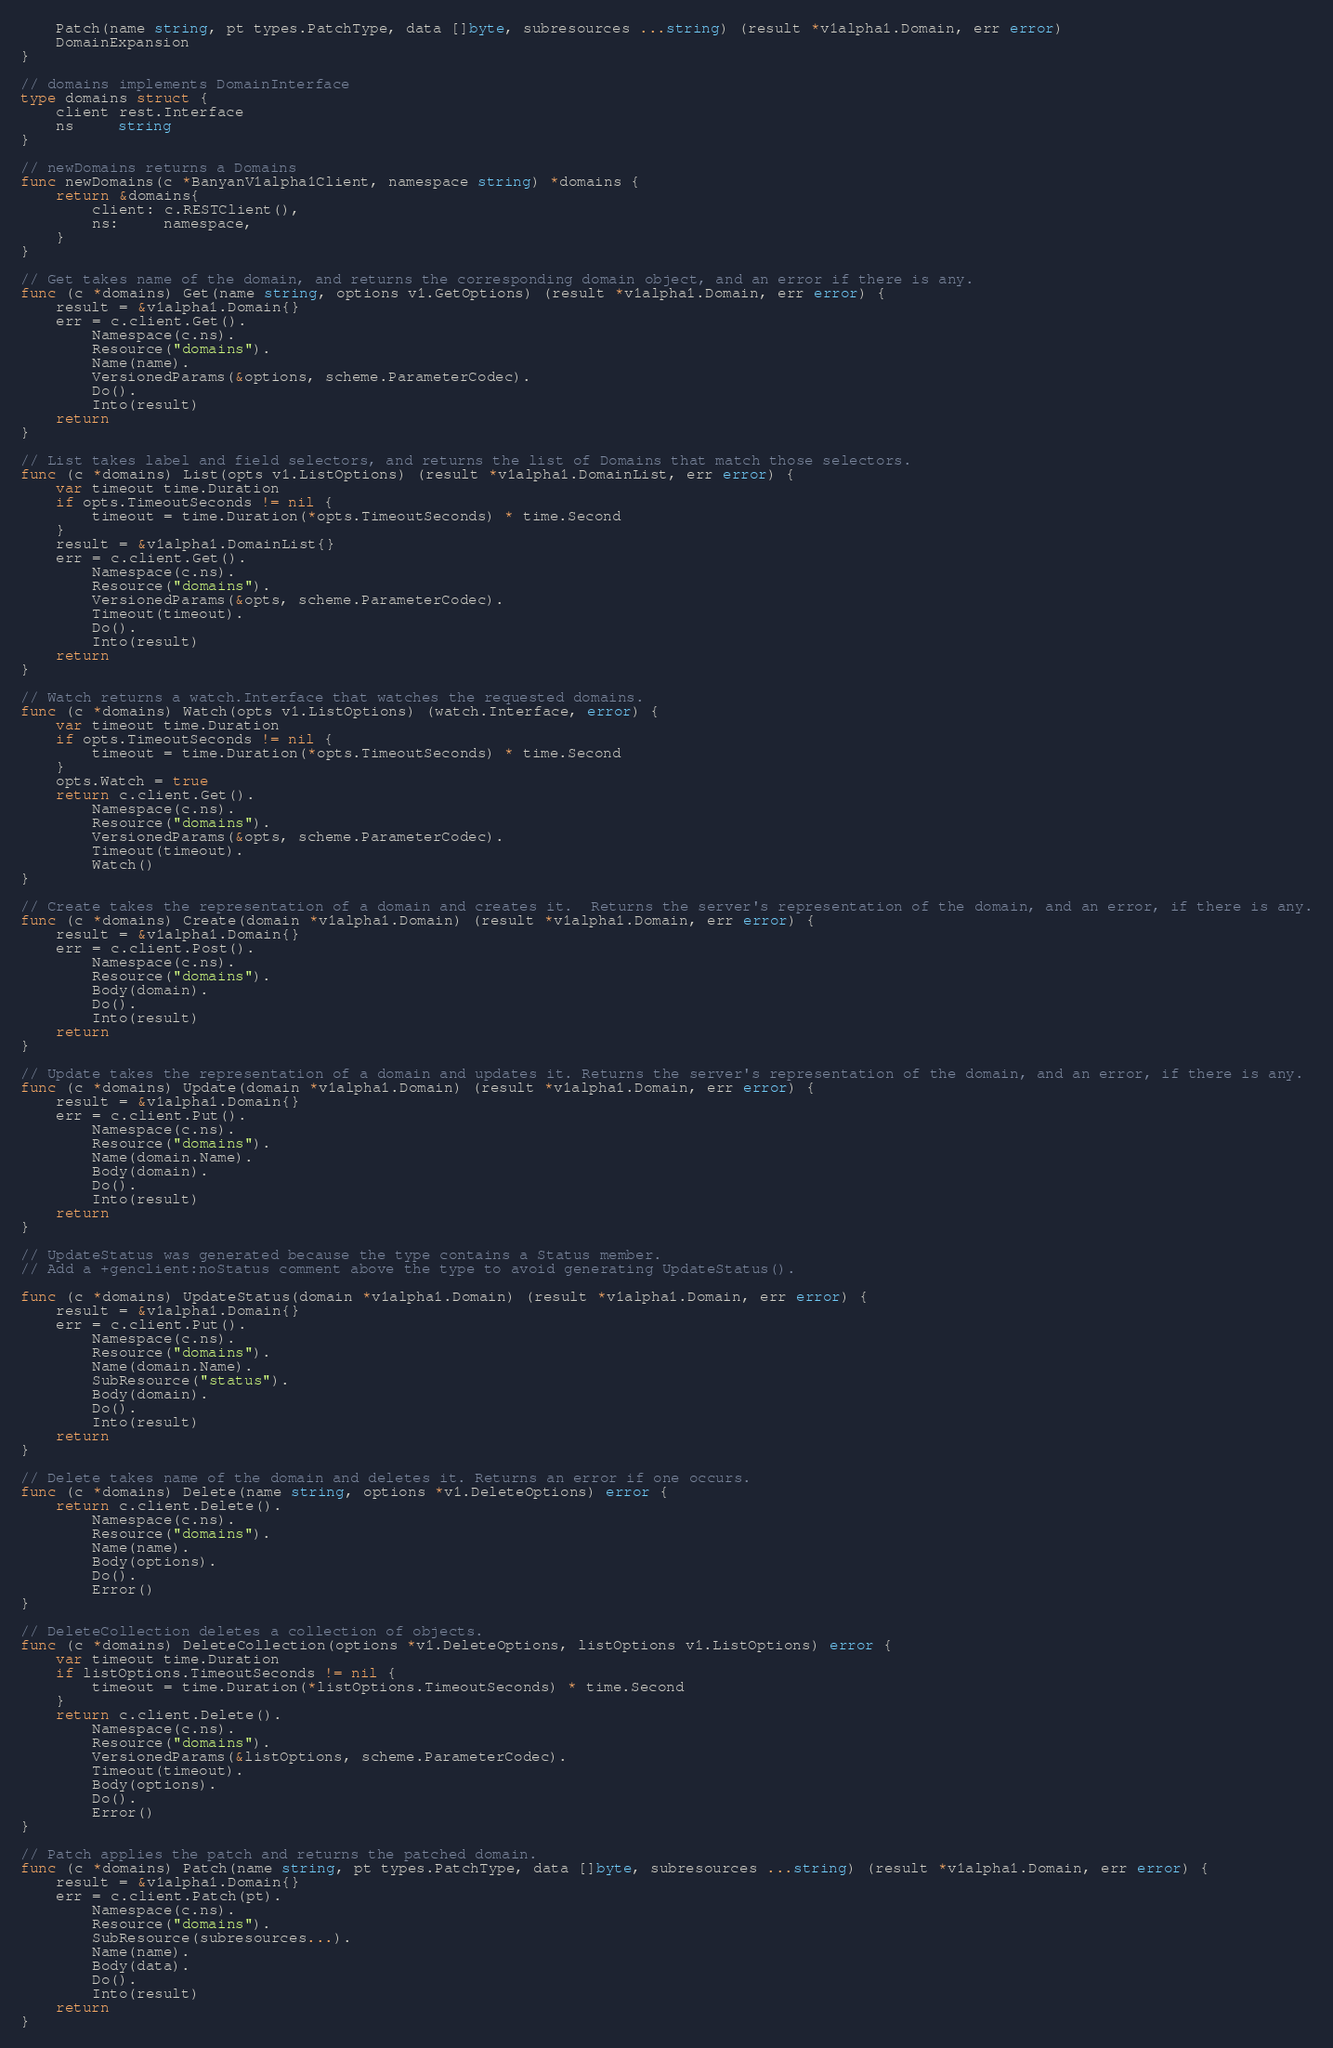Convert code to text. <code><loc_0><loc_0><loc_500><loc_500><_Go_>	Patch(name string, pt types.PatchType, data []byte, subresources ...string) (result *v1alpha1.Domain, err error)
	DomainExpansion
}

// domains implements DomainInterface
type domains struct {
	client rest.Interface
	ns     string
}

// newDomains returns a Domains
func newDomains(c *BanyanV1alpha1Client, namespace string) *domains {
	return &domains{
		client: c.RESTClient(),
		ns:     namespace,
	}
}

// Get takes name of the domain, and returns the corresponding domain object, and an error if there is any.
func (c *domains) Get(name string, options v1.GetOptions) (result *v1alpha1.Domain, err error) {
	result = &v1alpha1.Domain{}
	err = c.client.Get().
		Namespace(c.ns).
		Resource("domains").
		Name(name).
		VersionedParams(&options, scheme.ParameterCodec).
		Do().
		Into(result)
	return
}

// List takes label and field selectors, and returns the list of Domains that match those selectors.
func (c *domains) List(opts v1.ListOptions) (result *v1alpha1.DomainList, err error) {
	var timeout time.Duration
	if opts.TimeoutSeconds != nil {
		timeout = time.Duration(*opts.TimeoutSeconds) * time.Second
	}
	result = &v1alpha1.DomainList{}
	err = c.client.Get().
		Namespace(c.ns).
		Resource("domains").
		VersionedParams(&opts, scheme.ParameterCodec).
		Timeout(timeout).
		Do().
		Into(result)
	return
}

// Watch returns a watch.Interface that watches the requested domains.
func (c *domains) Watch(opts v1.ListOptions) (watch.Interface, error) {
	var timeout time.Duration
	if opts.TimeoutSeconds != nil {
		timeout = time.Duration(*opts.TimeoutSeconds) * time.Second
	}
	opts.Watch = true
	return c.client.Get().
		Namespace(c.ns).
		Resource("domains").
		VersionedParams(&opts, scheme.ParameterCodec).
		Timeout(timeout).
		Watch()
}

// Create takes the representation of a domain and creates it.  Returns the server's representation of the domain, and an error, if there is any.
func (c *domains) Create(domain *v1alpha1.Domain) (result *v1alpha1.Domain, err error) {
	result = &v1alpha1.Domain{}
	err = c.client.Post().
		Namespace(c.ns).
		Resource("domains").
		Body(domain).
		Do().
		Into(result)
	return
}

// Update takes the representation of a domain and updates it. Returns the server's representation of the domain, and an error, if there is any.
func (c *domains) Update(domain *v1alpha1.Domain) (result *v1alpha1.Domain, err error) {
	result = &v1alpha1.Domain{}
	err = c.client.Put().
		Namespace(c.ns).
		Resource("domains").
		Name(domain.Name).
		Body(domain).
		Do().
		Into(result)
	return
}

// UpdateStatus was generated because the type contains a Status member.
// Add a +genclient:noStatus comment above the type to avoid generating UpdateStatus().

func (c *domains) UpdateStatus(domain *v1alpha1.Domain) (result *v1alpha1.Domain, err error) {
	result = &v1alpha1.Domain{}
	err = c.client.Put().
		Namespace(c.ns).
		Resource("domains").
		Name(domain.Name).
		SubResource("status").
		Body(domain).
		Do().
		Into(result)
	return
}

// Delete takes name of the domain and deletes it. Returns an error if one occurs.
func (c *domains) Delete(name string, options *v1.DeleteOptions) error {
	return c.client.Delete().
		Namespace(c.ns).
		Resource("domains").
		Name(name).
		Body(options).
		Do().
		Error()
}

// DeleteCollection deletes a collection of objects.
func (c *domains) DeleteCollection(options *v1.DeleteOptions, listOptions v1.ListOptions) error {
	var timeout time.Duration
	if listOptions.TimeoutSeconds != nil {
		timeout = time.Duration(*listOptions.TimeoutSeconds) * time.Second
	}
	return c.client.Delete().
		Namespace(c.ns).
		Resource("domains").
		VersionedParams(&listOptions, scheme.ParameterCodec).
		Timeout(timeout).
		Body(options).
		Do().
		Error()
}

// Patch applies the patch and returns the patched domain.
func (c *domains) Patch(name string, pt types.PatchType, data []byte, subresources ...string) (result *v1alpha1.Domain, err error) {
	result = &v1alpha1.Domain{}
	err = c.client.Patch(pt).
		Namespace(c.ns).
		Resource("domains").
		SubResource(subresources...).
		Name(name).
		Body(data).
		Do().
		Into(result)
	return
}
</code> 